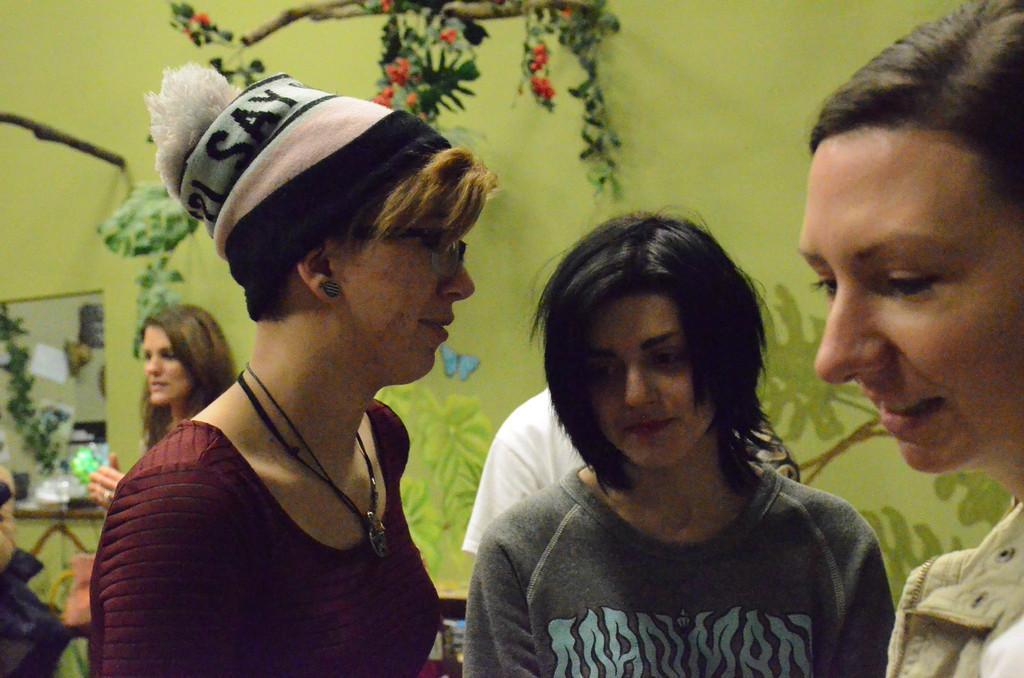In one or two sentences, can you explain what this image depicts? Here we can see people. Painting and mirror is on the wall. These are leaves and flowers. 